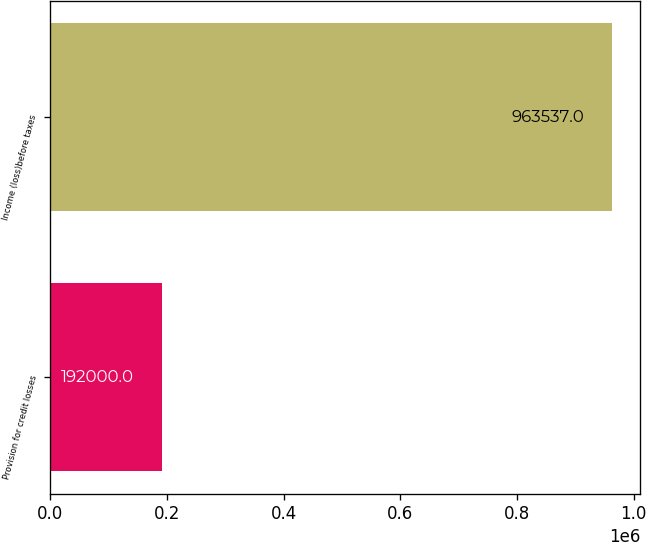Convert chart to OTSL. <chart><loc_0><loc_0><loc_500><loc_500><bar_chart><fcel>Provision for credit losses<fcel>Income (loss)before taxes<nl><fcel>192000<fcel>963537<nl></chart> 